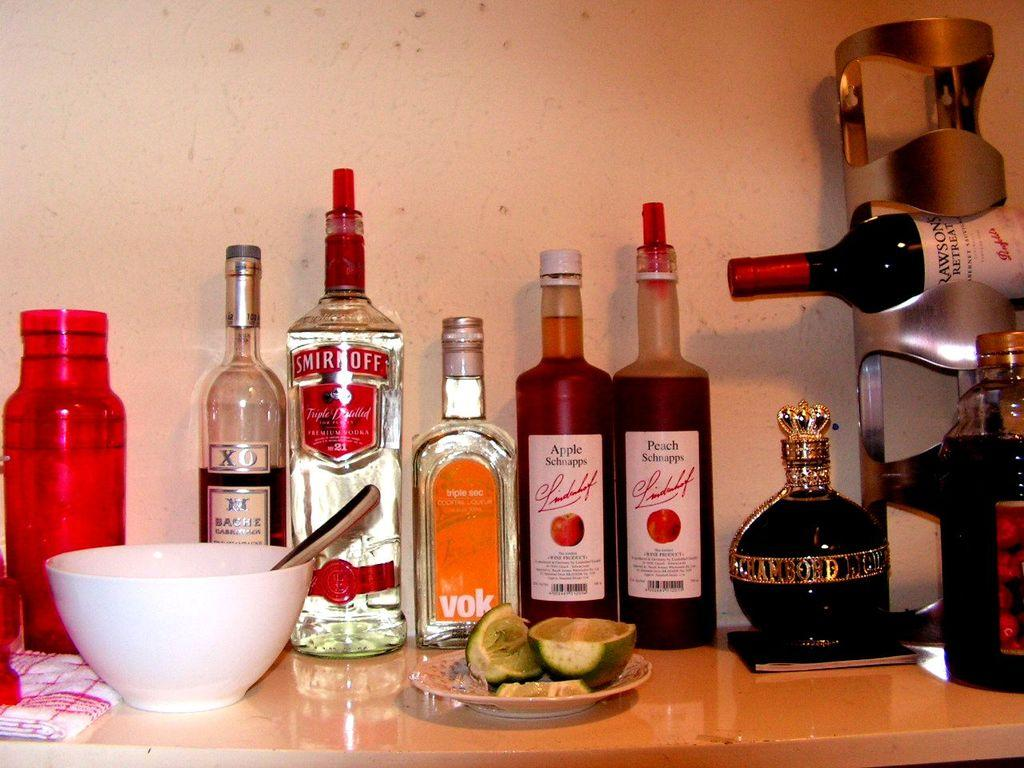<image>
Give a short and clear explanation of the subsequent image. a bottle of smirnoff bottle next to another bottle of vodka 